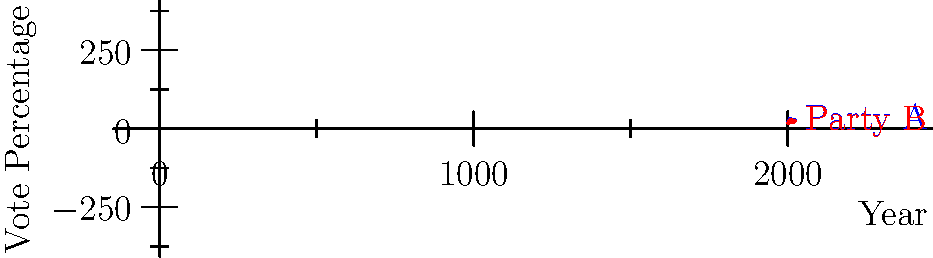Based on the voting trend graph for two major French political parties in presidential elections from 2002 to 2022, which party has shown more consistency in maintaining its voter base, and what strategic insight can be drawn from this trend? To answer this question, we need to analyze the voting trends for both parties:

1. Party A:
   - 2002: 19.9%
   - 2007: 31.2% (significant increase)
   - 2012: 28.6% (slight decrease)
   - 2017: 24.0% (notable decrease)
   - 2022: 27.9% (moderate increase)

2. Party B:
   - 2002: 16.9%
   - 2007: 25.9% (significant increase)
   - 2012: 27.2% (slight increase)
   - 2017: 21.3% (significant decrease)
   - 2022: 23.2% (moderate increase)

3. Consistency analysis:
   - Party A shows larger fluctuations, ranging from 19.9% to 31.2% (difference of 11.3 percentage points).
   - Party B shows smaller fluctuations, ranging from 16.9% to 27.2% (difference of 10.3 percentage points).

4. Trend analysis:
   - Both parties show similar overall patterns: increase from 2002 to 2007, relatively stable in 2012, decrease in 2017, and slight recovery in 2022.
   - Party B's trend line is slightly flatter, indicating more consistency.

5. Strategic insight:
   - Party B has maintained a more consistent voter base, with less extreme highs and lows.
   - This consistency suggests that Party B has a more stable core supporter group, which can be advantageous for long-term planning and strategy.
   - Party A, while experiencing higher peaks, also faces deeper troughs, indicating a more volatile support base that may be more susceptible to external factors or opposing campaigns.

Based on this analysis, Party B has shown more consistency in maintaining its voter base over the given period.
Answer: Party B; stable core support allows for more reliable long-term strategy. 